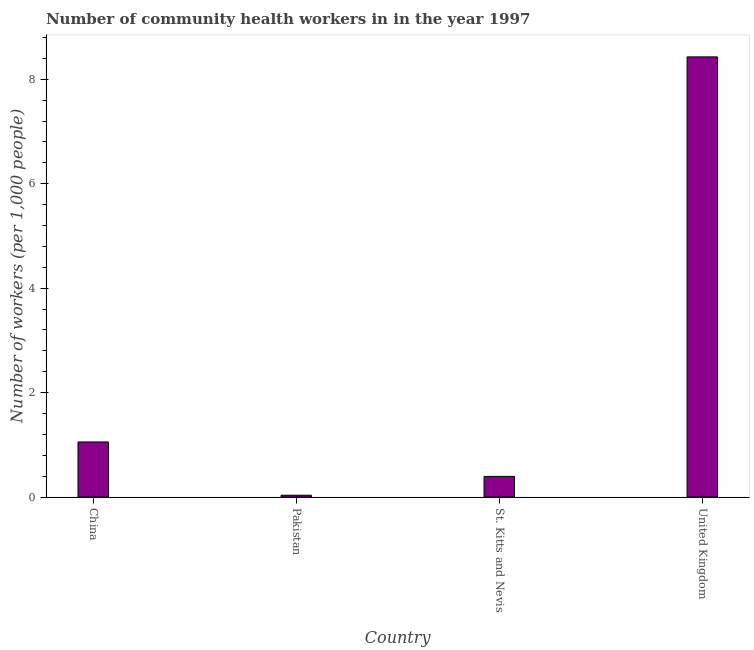What is the title of the graph?
Your answer should be compact. Number of community health workers in in the year 1997. What is the label or title of the Y-axis?
Your response must be concise. Number of workers (per 1,0 people). What is the number of community health workers in United Kingdom?
Give a very brief answer. 8.43. Across all countries, what is the maximum number of community health workers?
Provide a short and direct response. 8.43. Across all countries, what is the minimum number of community health workers?
Provide a succinct answer. 0.04. What is the sum of the number of community health workers?
Keep it short and to the point. 9.91. What is the difference between the number of community health workers in St. Kitts and Nevis and United Kingdom?
Your response must be concise. -8.04. What is the average number of community health workers per country?
Offer a terse response. 2.48. What is the median number of community health workers?
Make the answer very short. 0.72. What is the ratio of the number of community health workers in China to that in Pakistan?
Provide a short and direct response. 30.14. What is the difference between the highest and the second highest number of community health workers?
Keep it short and to the point. 7.38. Is the sum of the number of community health workers in Pakistan and St. Kitts and Nevis greater than the maximum number of community health workers across all countries?
Make the answer very short. No. What is the difference between the highest and the lowest number of community health workers?
Offer a terse response. 8.39. In how many countries, is the number of community health workers greater than the average number of community health workers taken over all countries?
Provide a succinct answer. 1. How many bars are there?
Provide a succinct answer. 4. Are all the bars in the graph horizontal?
Your answer should be very brief. No. Are the values on the major ticks of Y-axis written in scientific E-notation?
Offer a terse response. No. What is the Number of workers (per 1,000 people) of China?
Provide a short and direct response. 1.05. What is the Number of workers (per 1,000 people) of Pakistan?
Keep it short and to the point. 0.04. What is the Number of workers (per 1,000 people) of St. Kitts and Nevis?
Ensure brevity in your answer.  0.4. What is the Number of workers (per 1,000 people) in United Kingdom?
Make the answer very short. 8.43. What is the difference between the Number of workers (per 1,000 people) in China and Pakistan?
Keep it short and to the point. 1.02. What is the difference between the Number of workers (per 1,000 people) in China and St. Kitts and Nevis?
Your answer should be compact. 0.66. What is the difference between the Number of workers (per 1,000 people) in China and United Kingdom?
Give a very brief answer. -7.38. What is the difference between the Number of workers (per 1,000 people) in Pakistan and St. Kitts and Nevis?
Make the answer very short. -0.36. What is the difference between the Number of workers (per 1,000 people) in Pakistan and United Kingdom?
Give a very brief answer. -8.39. What is the difference between the Number of workers (per 1,000 people) in St. Kitts and Nevis and United Kingdom?
Keep it short and to the point. -8.04. What is the ratio of the Number of workers (per 1,000 people) in China to that in Pakistan?
Provide a short and direct response. 30.14. What is the ratio of the Number of workers (per 1,000 people) in China to that in St. Kitts and Nevis?
Your response must be concise. 2.67. What is the ratio of the Number of workers (per 1,000 people) in China to that in United Kingdom?
Your answer should be very brief. 0.12. What is the ratio of the Number of workers (per 1,000 people) in Pakistan to that in St. Kitts and Nevis?
Keep it short and to the point. 0.09. What is the ratio of the Number of workers (per 1,000 people) in Pakistan to that in United Kingdom?
Give a very brief answer. 0. What is the ratio of the Number of workers (per 1,000 people) in St. Kitts and Nevis to that in United Kingdom?
Your answer should be very brief. 0.05. 